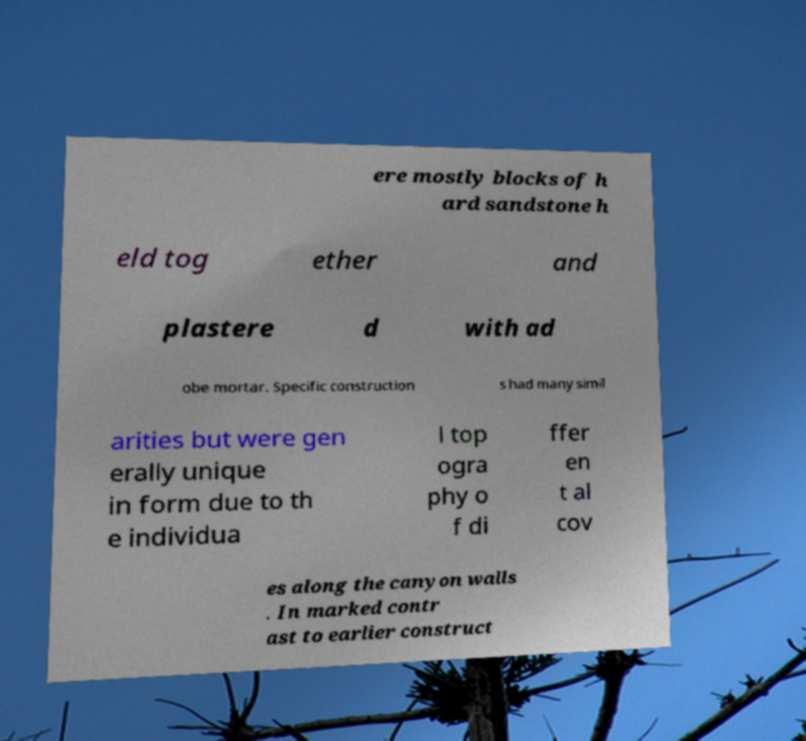For documentation purposes, I need the text within this image transcribed. Could you provide that? ere mostly blocks of h ard sandstone h eld tog ether and plastere d with ad obe mortar. Specific construction s had many simil arities but were gen erally unique in form due to th e individua l top ogra phy o f di ffer en t al cov es along the canyon walls . In marked contr ast to earlier construct 